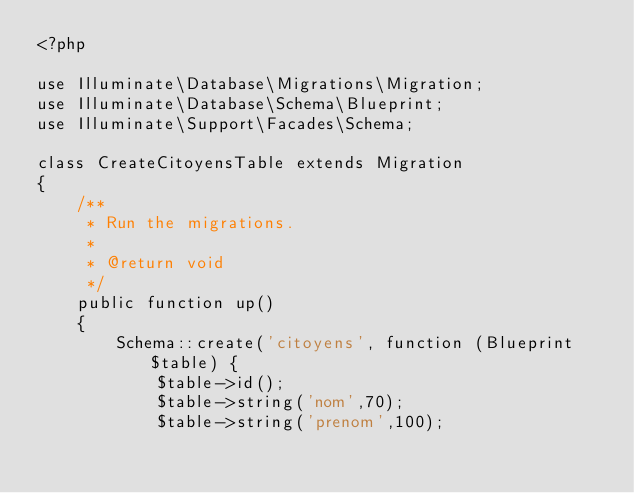<code> <loc_0><loc_0><loc_500><loc_500><_PHP_><?php

use Illuminate\Database\Migrations\Migration;
use Illuminate\Database\Schema\Blueprint;
use Illuminate\Support\Facades\Schema;

class CreateCitoyensTable extends Migration
{
    /**
     * Run the migrations.
     *
     * @return void
     */
    public function up()
    {
        Schema::create('citoyens', function (Blueprint $table) {
            $table->id();
            $table->string('nom',70);
            $table->string('prenom',100);</code> 